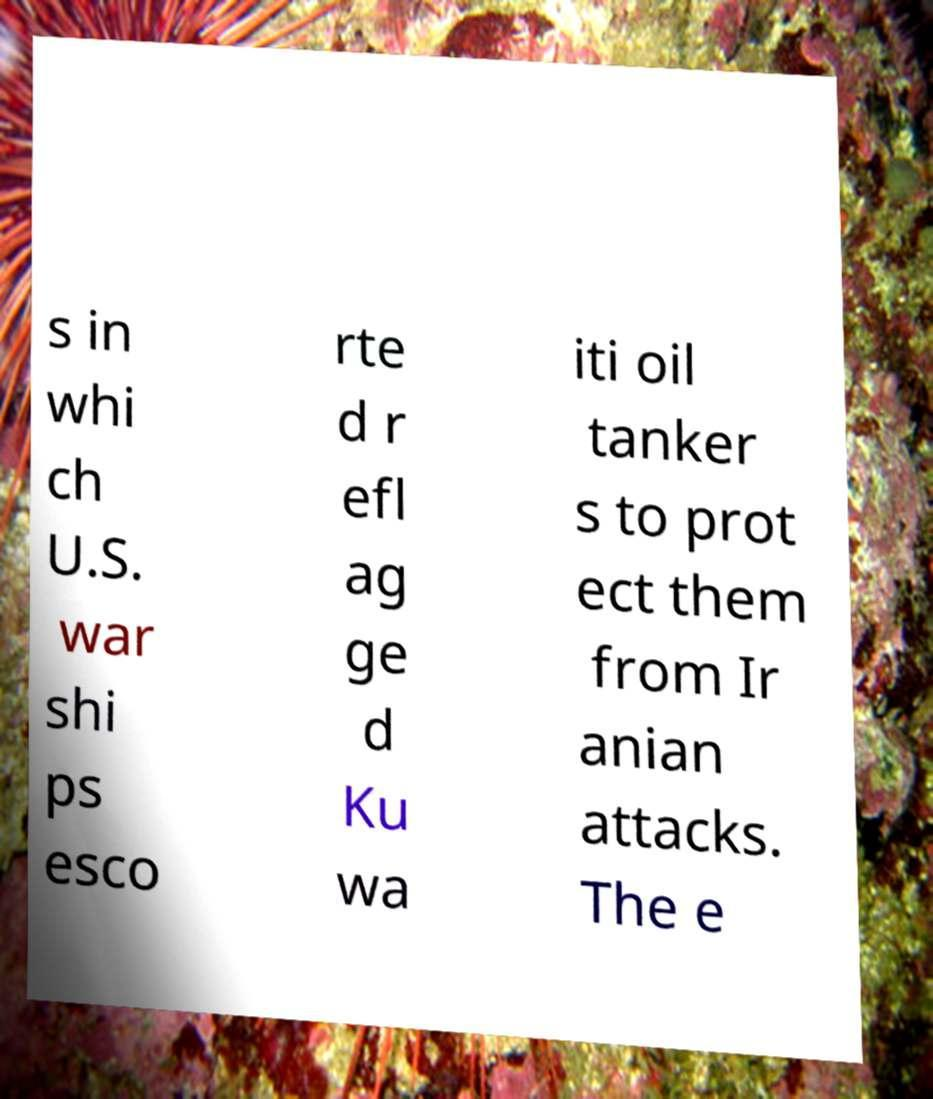Could you assist in decoding the text presented in this image and type it out clearly? s in whi ch U.S. war shi ps esco rte d r efl ag ge d Ku wa iti oil tanker s to prot ect them from Ir anian attacks. The e 